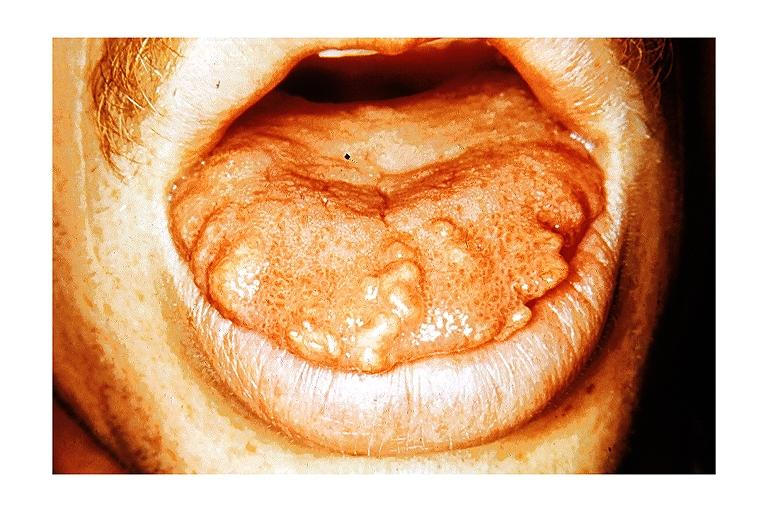where is this?
Answer the question using a single word or phrase. Oral 